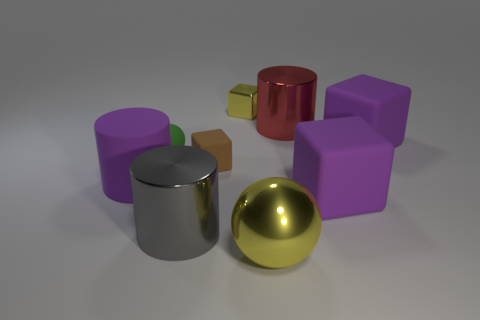Add 1 large purple rubber cylinders. How many objects exist? 10 Subtract all spheres. How many objects are left? 7 Add 3 small green spheres. How many small green spheres are left? 4 Add 8 large purple rubber cylinders. How many large purple rubber cylinders exist? 9 Subtract 0 green cubes. How many objects are left? 9 Subtract all large rubber objects. Subtract all small cubes. How many objects are left? 4 